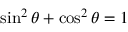<formula> <loc_0><loc_0><loc_500><loc_500>\sin ^ { 2 } \theta + \cos ^ { 2 } \theta = 1</formula> 